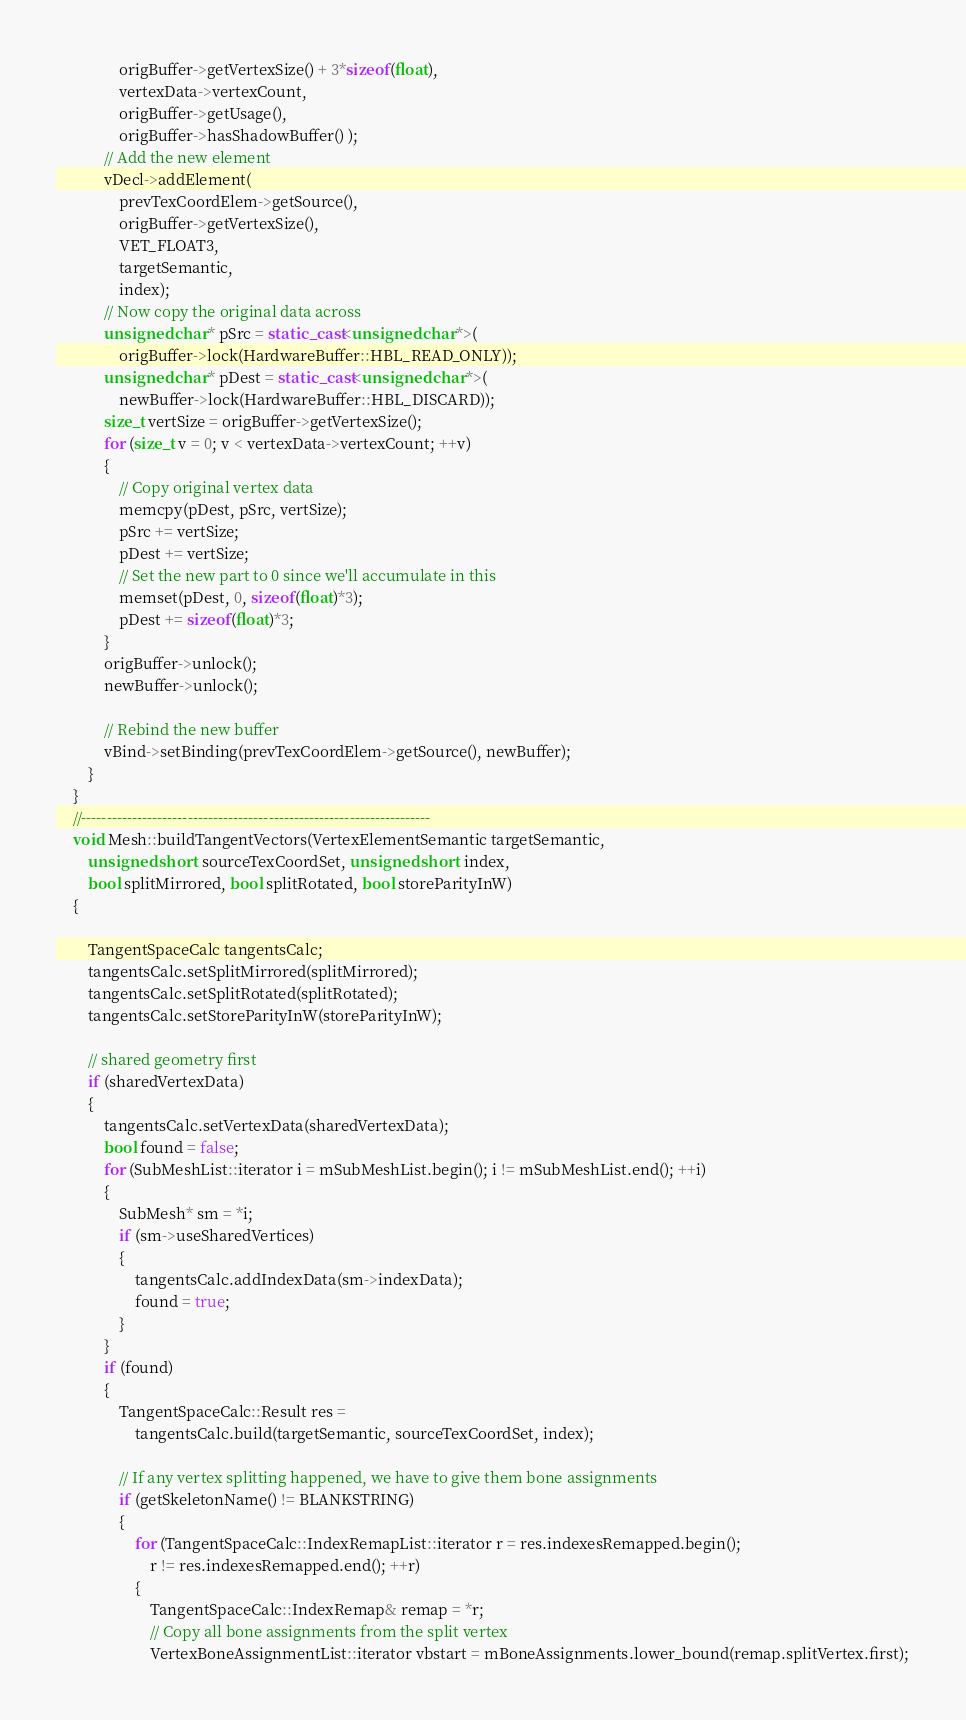<code> <loc_0><loc_0><loc_500><loc_500><_C++_>                origBuffer->getVertexSize() + 3*sizeof(float),
                vertexData->vertexCount,
                origBuffer->getUsage(),
                origBuffer->hasShadowBuffer() );
            // Add the new element
            vDecl->addElement(
                prevTexCoordElem->getSource(),
                origBuffer->getVertexSize(),
                VET_FLOAT3,
                targetSemantic,
                index);
            // Now copy the original data across
            unsigned char* pSrc = static_cast<unsigned char*>(
                origBuffer->lock(HardwareBuffer::HBL_READ_ONLY));
            unsigned char* pDest = static_cast<unsigned char*>(
                newBuffer->lock(HardwareBuffer::HBL_DISCARD));
            size_t vertSize = origBuffer->getVertexSize();
            for (size_t v = 0; v < vertexData->vertexCount; ++v)
            {
                // Copy original vertex data
                memcpy(pDest, pSrc, vertSize);
                pSrc += vertSize;
                pDest += vertSize;
                // Set the new part to 0 since we'll accumulate in this
                memset(pDest, 0, sizeof(float)*3);
                pDest += sizeof(float)*3;
            }
            origBuffer->unlock();
            newBuffer->unlock();

            // Rebind the new buffer
            vBind->setBinding(prevTexCoordElem->getSource(), newBuffer);
        }
    }
    //---------------------------------------------------------------------
    void Mesh::buildTangentVectors(VertexElementSemantic targetSemantic, 
        unsigned short sourceTexCoordSet, unsigned short index, 
        bool splitMirrored, bool splitRotated, bool storeParityInW)
    {

        TangentSpaceCalc tangentsCalc;
        tangentsCalc.setSplitMirrored(splitMirrored);
        tangentsCalc.setSplitRotated(splitRotated);
        tangentsCalc.setStoreParityInW(storeParityInW);

        // shared geometry first
        if (sharedVertexData)
        {
            tangentsCalc.setVertexData(sharedVertexData);
            bool found = false;
            for (SubMeshList::iterator i = mSubMeshList.begin(); i != mSubMeshList.end(); ++i)
            {
                SubMesh* sm = *i;
                if (sm->useSharedVertices)
                {
                    tangentsCalc.addIndexData(sm->indexData);
                    found = true;
                }
            }
            if (found)
            {
                TangentSpaceCalc::Result res = 
                    tangentsCalc.build(targetSemantic, sourceTexCoordSet, index);

                // If any vertex splitting happened, we have to give them bone assignments
                if (getSkeletonName() != BLANKSTRING)
                {
                    for (TangentSpaceCalc::IndexRemapList::iterator r = res.indexesRemapped.begin(); 
                        r != res.indexesRemapped.end(); ++r)
                    {
                        TangentSpaceCalc::IndexRemap& remap = *r;
                        // Copy all bone assignments from the split vertex
                        VertexBoneAssignmentList::iterator vbstart = mBoneAssignments.lower_bound(remap.splitVertex.first);</code> 